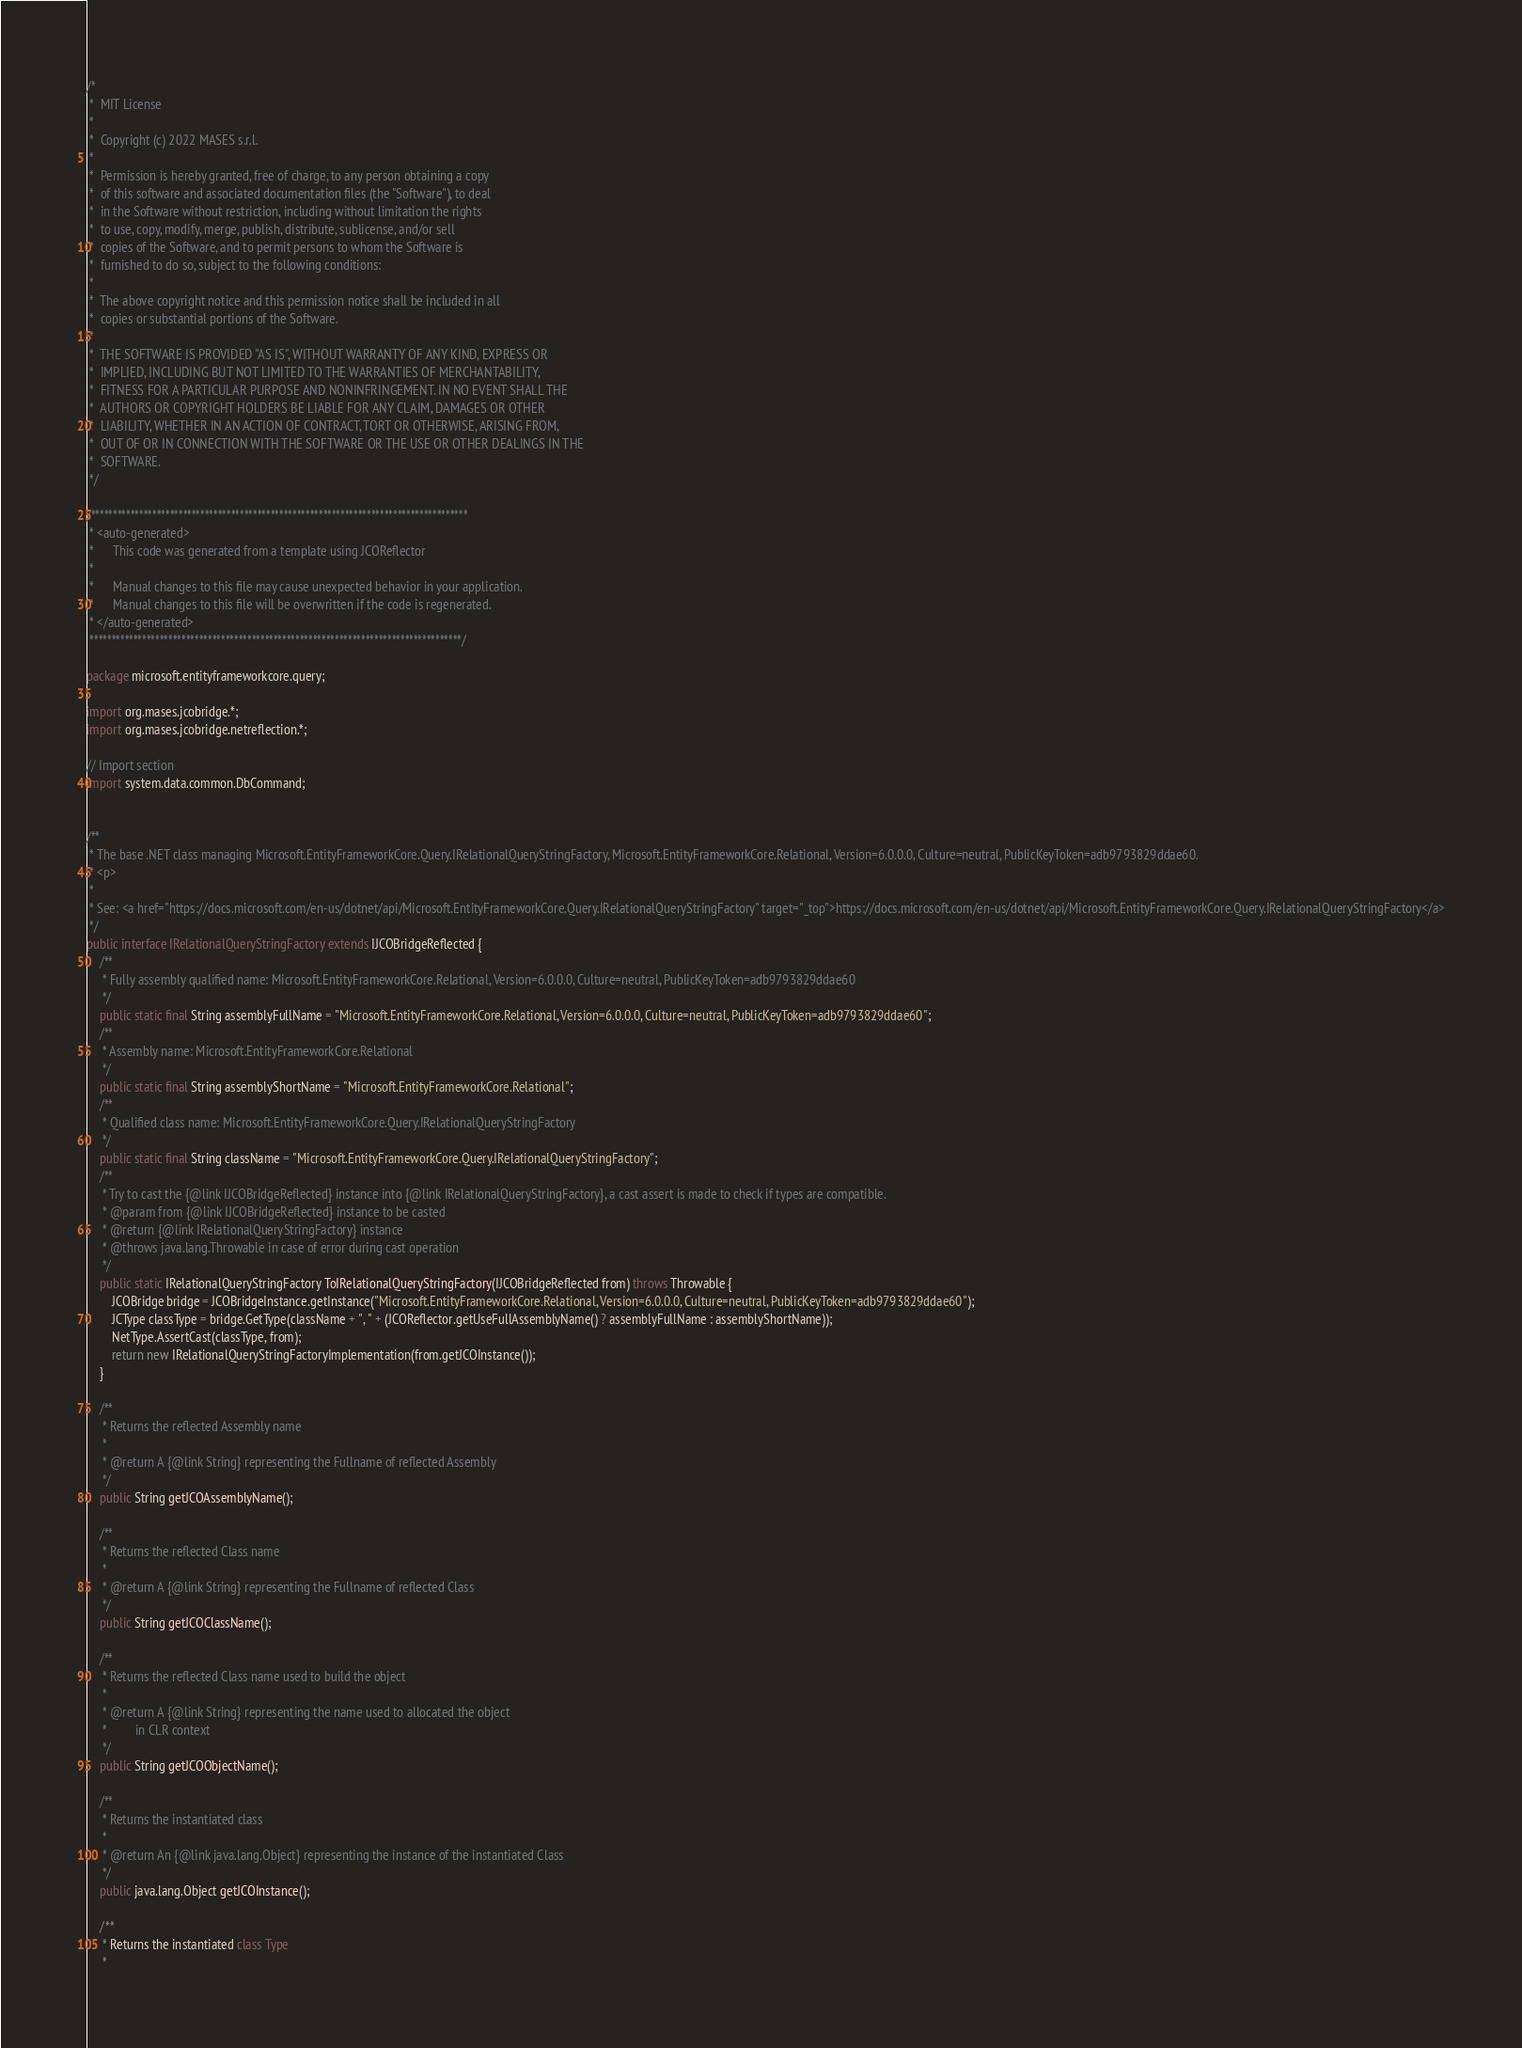Convert code to text. <code><loc_0><loc_0><loc_500><loc_500><_Java_>/*
 *  MIT License
 *
 *  Copyright (c) 2022 MASES s.r.l.
 *
 *  Permission is hereby granted, free of charge, to any person obtaining a copy
 *  of this software and associated documentation files (the "Software"), to deal
 *  in the Software without restriction, including without limitation the rights
 *  to use, copy, modify, merge, publish, distribute, sublicense, and/or sell
 *  copies of the Software, and to permit persons to whom the Software is
 *  furnished to do so, subject to the following conditions:
 *
 *  The above copyright notice and this permission notice shall be included in all
 *  copies or substantial portions of the Software.
 *
 *  THE SOFTWARE IS PROVIDED "AS IS", WITHOUT WARRANTY OF ANY KIND, EXPRESS OR
 *  IMPLIED, INCLUDING BUT NOT LIMITED TO THE WARRANTIES OF MERCHANTABILITY,
 *  FITNESS FOR A PARTICULAR PURPOSE AND NONINFRINGEMENT. IN NO EVENT SHALL THE
 *  AUTHORS OR COPYRIGHT HOLDERS BE LIABLE FOR ANY CLAIM, DAMAGES OR OTHER
 *  LIABILITY, WHETHER IN AN ACTION OF CONTRACT, TORT OR OTHERWISE, ARISING FROM,
 *  OUT OF OR IN CONNECTION WITH THE SOFTWARE OR THE USE OR OTHER DEALINGS IN THE
 *  SOFTWARE.
 */

/**************************************************************************************
 * <auto-generated>
 *      This code was generated from a template using JCOReflector
 * 
 *      Manual changes to this file may cause unexpected behavior in your application.
 *      Manual changes to this file will be overwritten if the code is regenerated.
 * </auto-generated>
 *************************************************************************************/

package microsoft.entityframeworkcore.query;

import org.mases.jcobridge.*;
import org.mases.jcobridge.netreflection.*;

// Import section
import system.data.common.DbCommand;


/**
 * The base .NET class managing Microsoft.EntityFrameworkCore.Query.IRelationalQueryStringFactory, Microsoft.EntityFrameworkCore.Relational, Version=6.0.0.0, Culture=neutral, PublicKeyToken=adb9793829ddae60.
 * <p>
 * 
 * See: <a href="https://docs.microsoft.com/en-us/dotnet/api/Microsoft.EntityFrameworkCore.Query.IRelationalQueryStringFactory" target="_top">https://docs.microsoft.com/en-us/dotnet/api/Microsoft.EntityFrameworkCore.Query.IRelationalQueryStringFactory</a>
 */
public interface IRelationalQueryStringFactory extends IJCOBridgeReflected {
    /**
     * Fully assembly qualified name: Microsoft.EntityFrameworkCore.Relational, Version=6.0.0.0, Culture=neutral, PublicKeyToken=adb9793829ddae60
     */
    public static final String assemblyFullName = "Microsoft.EntityFrameworkCore.Relational, Version=6.0.0.0, Culture=neutral, PublicKeyToken=adb9793829ddae60";
    /**
     * Assembly name: Microsoft.EntityFrameworkCore.Relational
     */
    public static final String assemblyShortName = "Microsoft.EntityFrameworkCore.Relational";
    /**
     * Qualified class name: Microsoft.EntityFrameworkCore.Query.IRelationalQueryStringFactory
     */
    public static final String className = "Microsoft.EntityFrameworkCore.Query.IRelationalQueryStringFactory";
    /**
     * Try to cast the {@link IJCOBridgeReflected} instance into {@link IRelationalQueryStringFactory}, a cast assert is made to check if types are compatible.
     * @param from {@link IJCOBridgeReflected} instance to be casted
     * @return {@link IRelationalQueryStringFactory} instance
     * @throws java.lang.Throwable in case of error during cast operation
     */
    public static IRelationalQueryStringFactory ToIRelationalQueryStringFactory(IJCOBridgeReflected from) throws Throwable {
        JCOBridge bridge = JCOBridgeInstance.getInstance("Microsoft.EntityFrameworkCore.Relational, Version=6.0.0.0, Culture=neutral, PublicKeyToken=adb9793829ddae60");
        JCType classType = bridge.GetType(className + ", " + (JCOReflector.getUseFullAssemblyName() ? assemblyFullName : assemblyShortName));
        NetType.AssertCast(classType, from);
        return new IRelationalQueryStringFactoryImplementation(from.getJCOInstance());
    }

    /**
     * Returns the reflected Assembly name
     * 
     * @return A {@link String} representing the Fullname of reflected Assembly
     */
    public String getJCOAssemblyName();

    /**
     * Returns the reflected Class name
     * 
     * @return A {@link String} representing the Fullname of reflected Class
     */
    public String getJCOClassName();

    /**
     * Returns the reflected Class name used to build the object
     * 
     * @return A {@link String} representing the name used to allocated the object
     *         in CLR context
     */
    public String getJCOObjectName();

    /**
     * Returns the instantiated class
     * 
     * @return An {@link java.lang.Object} representing the instance of the instantiated Class
     */
    public java.lang.Object getJCOInstance();

    /**
     * Returns the instantiated class Type
     * </code> 